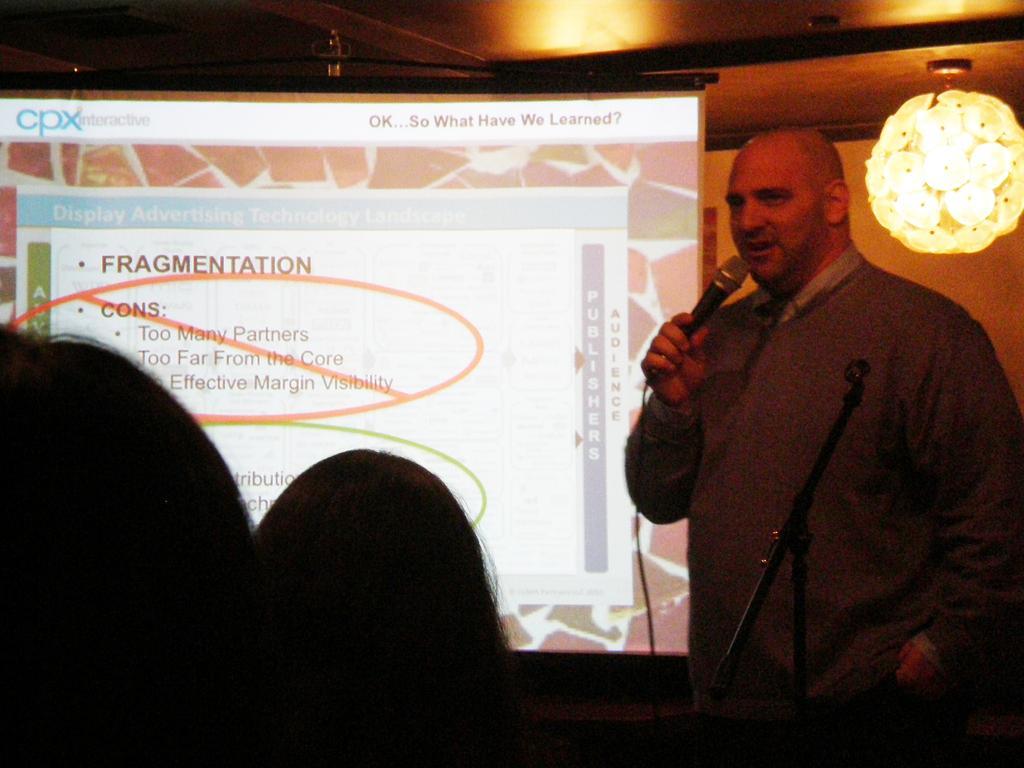Describe this image in one or two sentences. In this image we can see a person standing and holding microphone in his hands, on left side of the image there are some persons sitting and in the background of the image there is projector screen on which some video is displaying and e can see some lights, roof. 